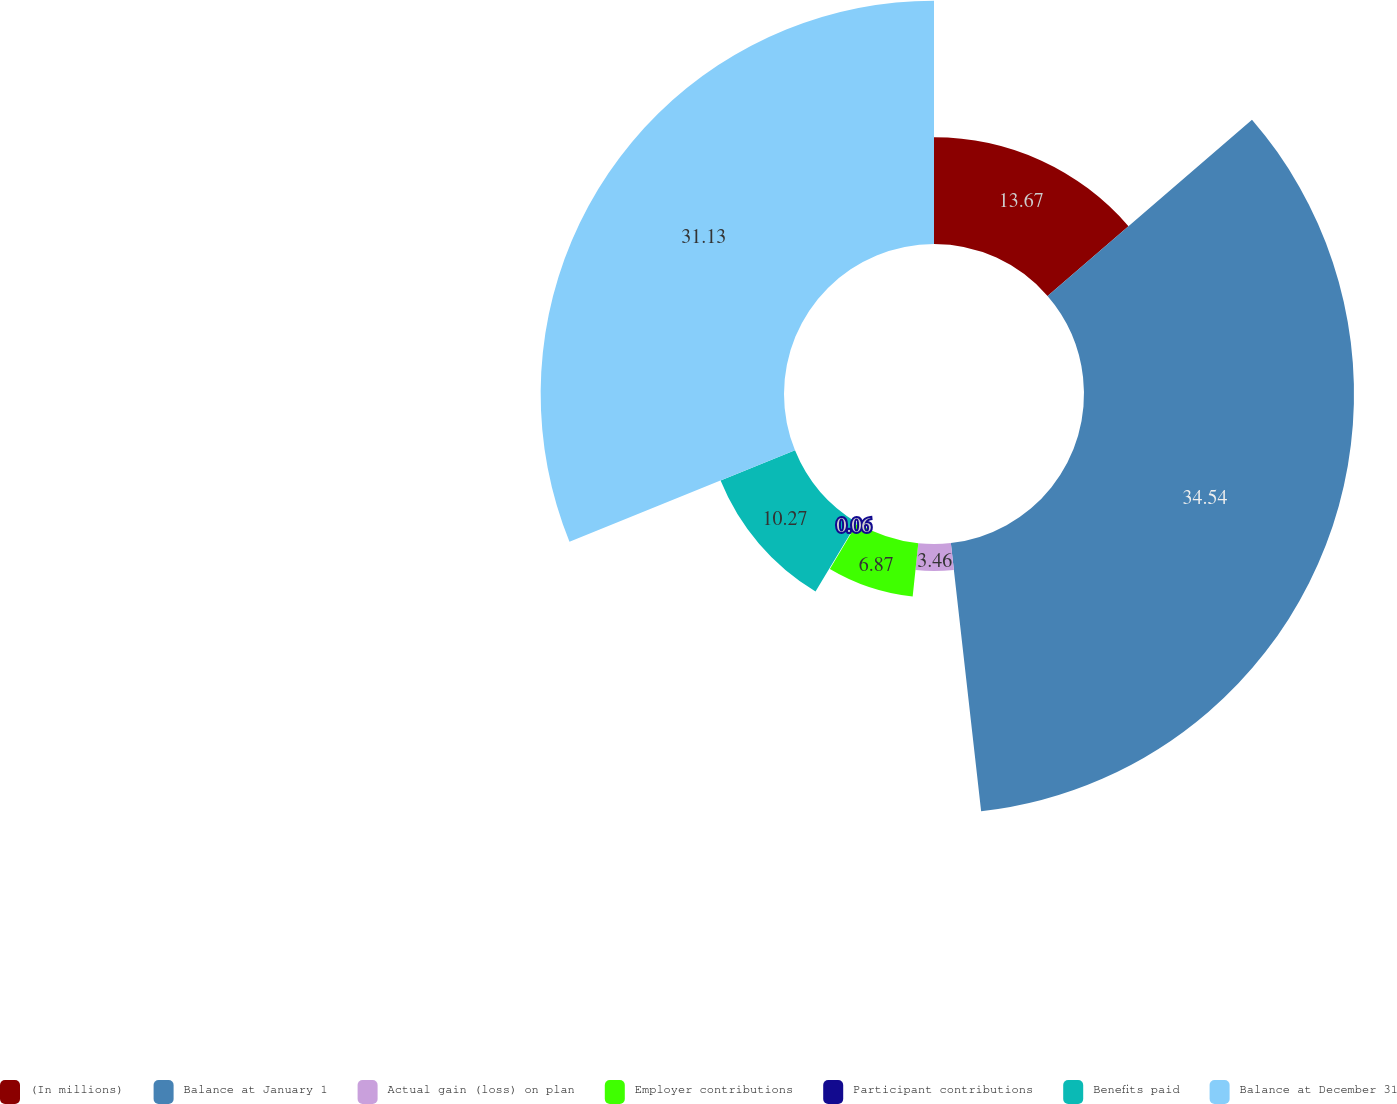Convert chart to OTSL. <chart><loc_0><loc_0><loc_500><loc_500><pie_chart><fcel>(In millions)<fcel>Balance at January 1<fcel>Actual gain (loss) on plan<fcel>Employer contributions<fcel>Participant contributions<fcel>Benefits paid<fcel>Balance at December 31<nl><fcel>13.67%<fcel>34.54%<fcel>3.46%<fcel>6.87%<fcel>0.06%<fcel>10.27%<fcel>31.13%<nl></chart> 